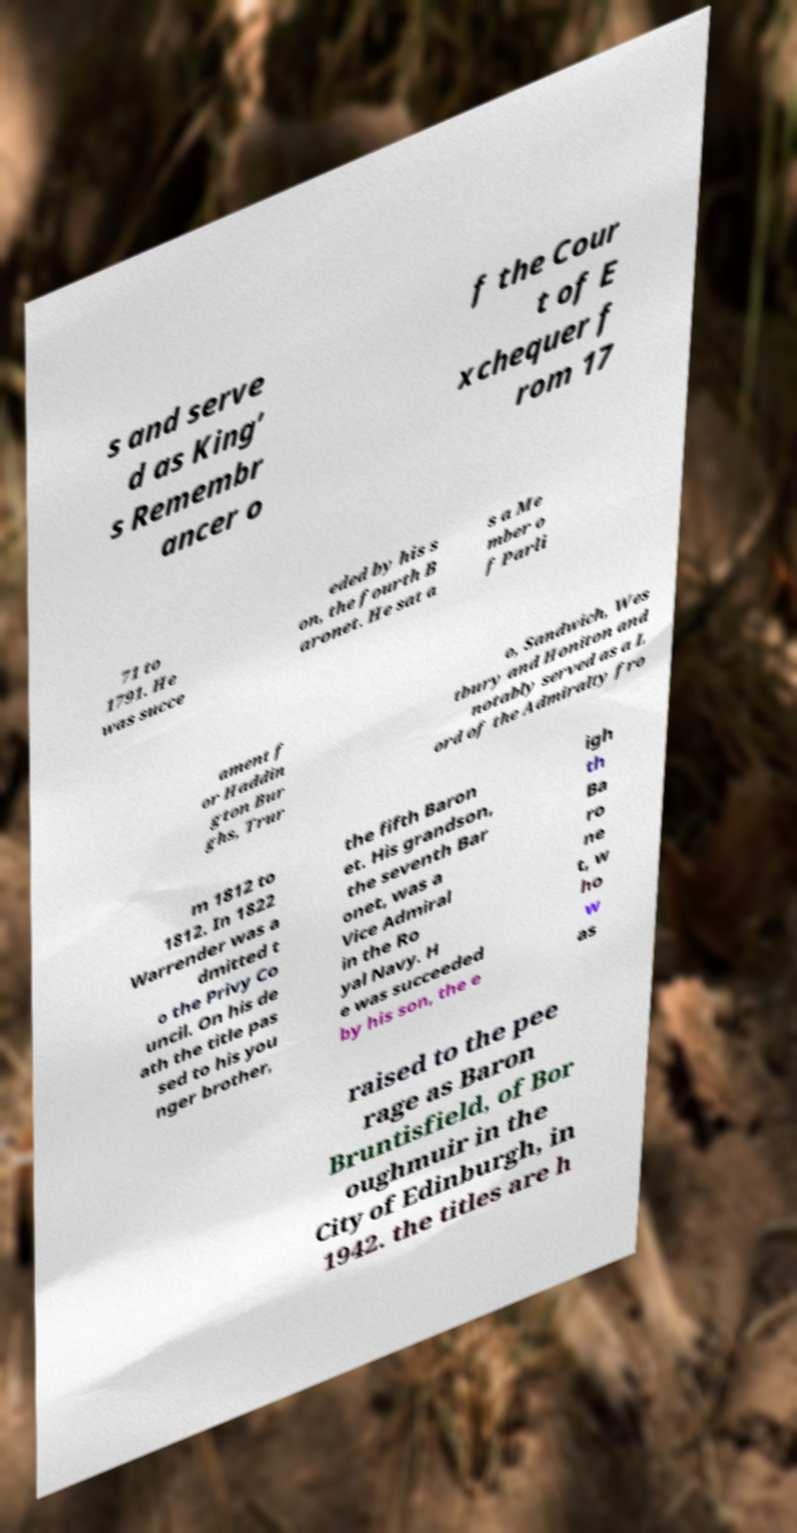I need the written content from this picture converted into text. Can you do that? s and serve d as King’ s Remembr ancer o f the Cour t of E xchequer f rom 17 71 to 1791. He was succe eded by his s on, the fourth B aronet. He sat a s a Me mber o f Parli ament f or Haddin gton Bur ghs, Trur o, Sandwich, Wes tbury and Honiton and notably served as a L ord of the Admiralty fro m 1812 to 1812. In 1822 Warrender was a dmitted t o the Privy Co uncil. On his de ath the title pas sed to his you nger brother, the fifth Baron et. His grandson, the seventh Bar onet, was a Vice Admiral in the Ro yal Navy. H e was succeeded by his son, the e igh th Ba ro ne t, w ho w as raised to the pee rage as Baron Bruntisfield, of Bor oughmuir in the City of Edinburgh, in 1942. the titles are h 